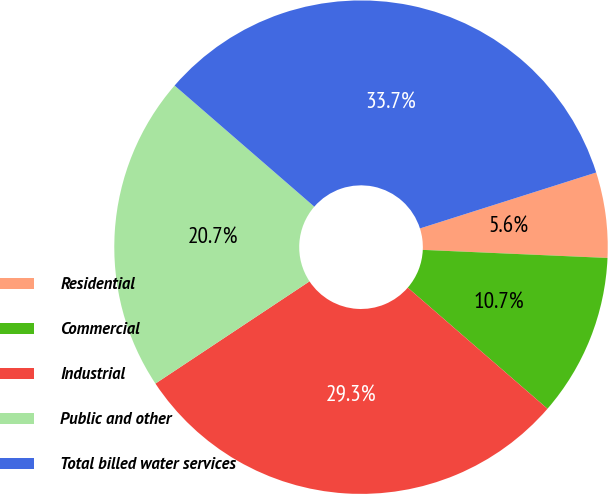Convert chart to OTSL. <chart><loc_0><loc_0><loc_500><loc_500><pie_chart><fcel>Residential<fcel>Commercial<fcel>Industrial<fcel>Public and other<fcel>Total billed water services<nl><fcel>5.59%<fcel>10.67%<fcel>29.31%<fcel>20.69%<fcel>33.74%<nl></chart> 